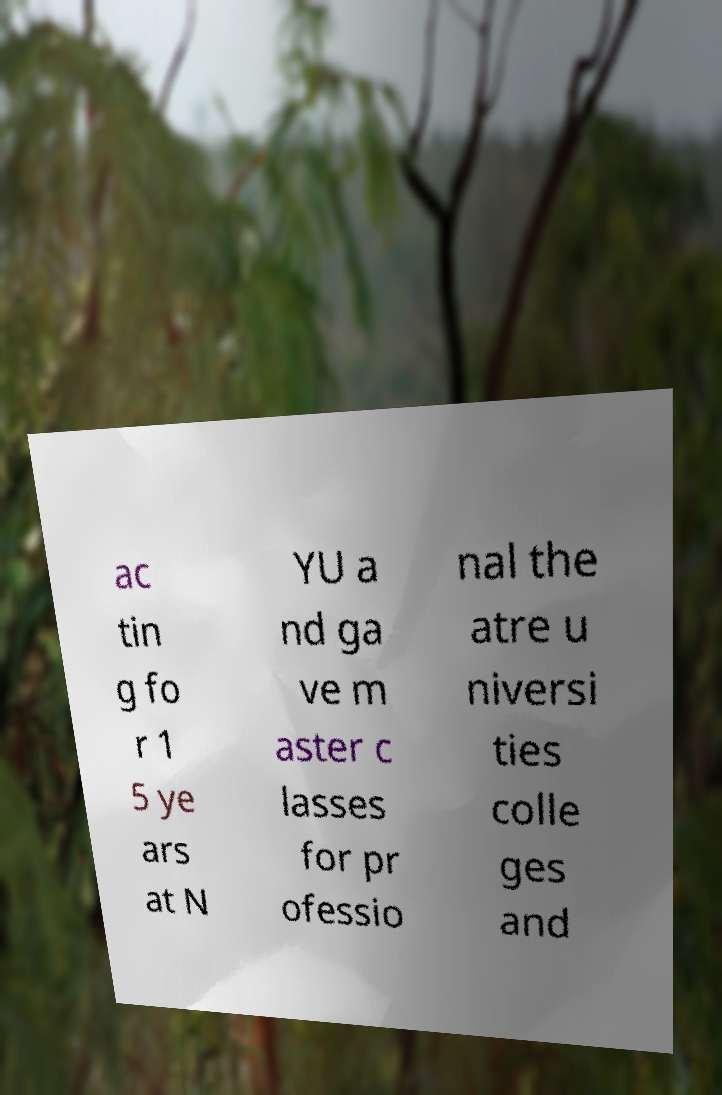Can you accurately transcribe the text from the provided image for me? ac tin g fo r 1 5 ye ars at N YU a nd ga ve m aster c lasses for pr ofessio nal the atre u niversi ties colle ges and 